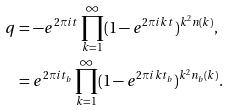<formula> <loc_0><loc_0><loc_500><loc_500>q & = - e ^ { 2 \pi i t } \prod _ { k = 1 } ^ { \infty } ( 1 - e ^ { 2 \pi i k t } ) ^ { k ^ { 2 } n ( k ) } , \\ & = e ^ { 2 \pi i t _ { b } } \prod _ { k = 1 } ^ { \infty } ( 1 - e ^ { 2 \pi i k t _ { b } } ) ^ { k ^ { 2 } n _ { b } ( k ) } .</formula> 